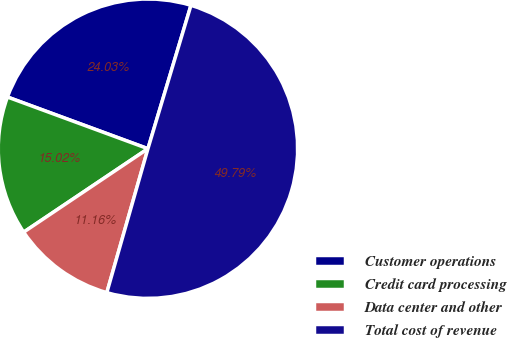Convert chart. <chart><loc_0><loc_0><loc_500><loc_500><pie_chart><fcel>Customer operations<fcel>Credit card processing<fcel>Data center and other<fcel>Total cost of revenue<nl><fcel>24.03%<fcel>15.02%<fcel>11.16%<fcel>49.79%<nl></chart> 